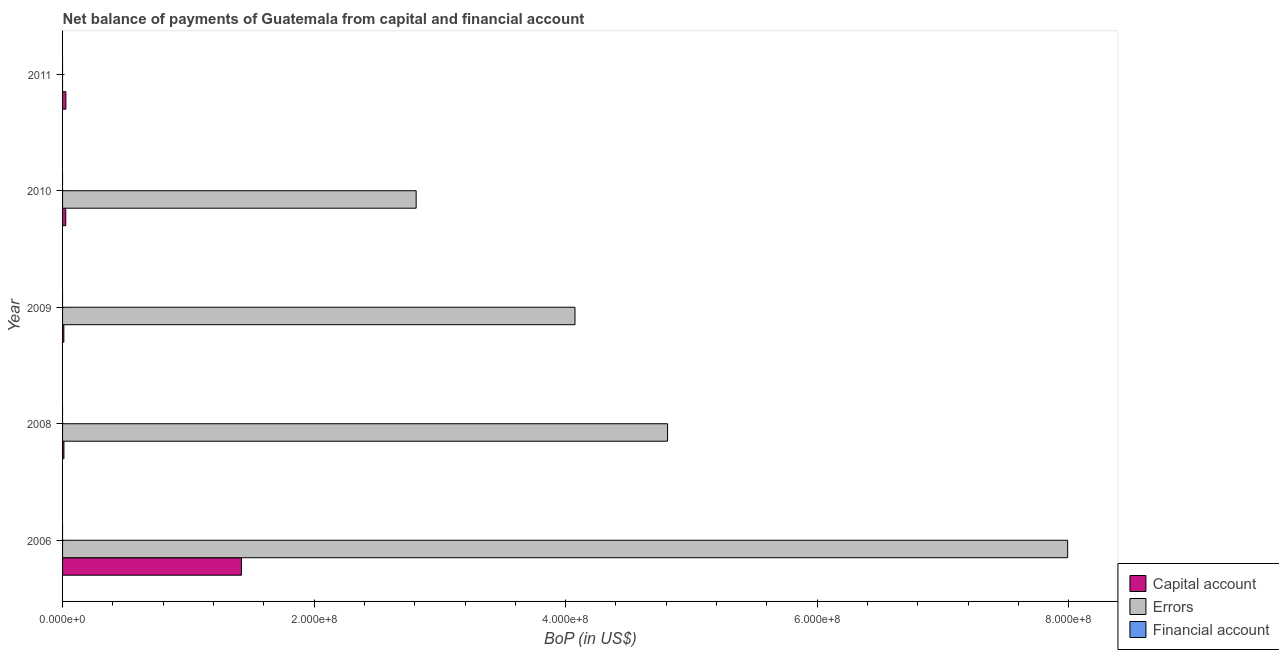How many different coloured bars are there?
Provide a short and direct response. 2. Are the number of bars on each tick of the Y-axis equal?
Keep it short and to the point. No. In how many cases, is the number of bars for a given year not equal to the number of legend labels?
Your answer should be very brief. 5. What is the amount of errors in 2008?
Your answer should be compact. 4.81e+08. Across all years, what is the maximum amount of errors?
Your answer should be very brief. 7.99e+08. Across all years, what is the minimum amount of net capital account?
Ensure brevity in your answer.  1.01e+06. In which year was the amount of errors maximum?
Make the answer very short. 2006. What is the total amount of financial account in the graph?
Give a very brief answer. 0. What is the difference between the amount of errors in 2008 and that in 2009?
Provide a short and direct response. 7.36e+07. What is the difference between the amount of financial account in 2006 and the amount of errors in 2008?
Provide a succinct answer. -4.81e+08. What is the average amount of net capital account per year?
Provide a succinct answer. 2.99e+07. In the year 2008, what is the difference between the amount of net capital account and amount of errors?
Offer a very short reply. -4.80e+08. In how many years, is the amount of net capital account greater than 280000000 US$?
Your response must be concise. 0. What is the ratio of the amount of net capital account in 2006 to that in 2009?
Your response must be concise. 140.53. Is the difference between the amount of net capital account in 2008 and 2009 greater than the difference between the amount of errors in 2008 and 2009?
Give a very brief answer. No. What is the difference between the highest and the second highest amount of errors?
Provide a succinct answer. 3.18e+08. What is the difference between the highest and the lowest amount of errors?
Your answer should be compact. 7.99e+08. In how many years, is the amount of financial account greater than the average amount of financial account taken over all years?
Provide a short and direct response. 0. Is the sum of the amount of net capital account in 2009 and 2010 greater than the maximum amount of financial account across all years?
Your response must be concise. Yes. Is it the case that in every year, the sum of the amount of net capital account and amount of errors is greater than the amount of financial account?
Give a very brief answer. Yes. How many bars are there?
Your answer should be compact. 9. How many years are there in the graph?
Your answer should be very brief. 5. What is the difference between two consecutive major ticks on the X-axis?
Your answer should be very brief. 2.00e+08. Are the values on the major ticks of X-axis written in scientific E-notation?
Ensure brevity in your answer.  Yes. Where does the legend appear in the graph?
Your response must be concise. Bottom right. What is the title of the graph?
Ensure brevity in your answer.  Net balance of payments of Guatemala from capital and financial account. What is the label or title of the X-axis?
Keep it short and to the point. BoP (in US$). What is the BoP (in US$) of Capital account in 2006?
Give a very brief answer. 1.42e+08. What is the BoP (in US$) of Errors in 2006?
Make the answer very short. 7.99e+08. What is the BoP (in US$) of Capital account in 2008?
Ensure brevity in your answer.  1.08e+06. What is the BoP (in US$) of Errors in 2008?
Give a very brief answer. 4.81e+08. What is the BoP (in US$) in Financial account in 2008?
Keep it short and to the point. 0. What is the BoP (in US$) of Capital account in 2009?
Provide a short and direct response. 1.01e+06. What is the BoP (in US$) of Errors in 2009?
Offer a very short reply. 4.07e+08. What is the BoP (in US$) in Financial account in 2009?
Your answer should be compact. 0. What is the BoP (in US$) of Capital account in 2010?
Keep it short and to the point. 2.53e+06. What is the BoP (in US$) in Errors in 2010?
Keep it short and to the point. 2.81e+08. What is the BoP (in US$) in Financial account in 2010?
Make the answer very short. 0. What is the BoP (in US$) of Capital account in 2011?
Your answer should be very brief. 2.63e+06. What is the BoP (in US$) in Errors in 2011?
Provide a short and direct response. 0. What is the BoP (in US$) of Financial account in 2011?
Offer a terse response. 0. Across all years, what is the maximum BoP (in US$) in Capital account?
Keep it short and to the point. 1.42e+08. Across all years, what is the maximum BoP (in US$) of Errors?
Ensure brevity in your answer.  7.99e+08. Across all years, what is the minimum BoP (in US$) in Capital account?
Provide a succinct answer. 1.01e+06. What is the total BoP (in US$) in Capital account in the graph?
Offer a terse response. 1.49e+08. What is the total BoP (in US$) of Errors in the graph?
Make the answer very short. 1.97e+09. What is the total BoP (in US$) of Financial account in the graph?
Offer a terse response. 0. What is the difference between the BoP (in US$) in Capital account in 2006 and that in 2008?
Offer a very short reply. 1.41e+08. What is the difference between the BoP (in US$) in Errors in 2006 and that in 2008?
Provide a succinct answer. 3.18e+08. What is the difference between the BoP (in US$) in Capital account in 2006 and that in 2009?
Provide a short and direct response. 1.41e+08. What is the difference between the BoP (in US$) of Errors in 2006 and that in 2009?
Provide a succinct answer. 3.92e+08. What is the difference between the BoP (in US$) in Capital account in 2006 and that in 2010?
Your response must be concise. 1.40e+08. What is the difference between the BoP (in US$) in Errors in 2006 and that in 2010?
Offer a very short reply. 5.18e+08. What is the difference between the BoP (in US$) in Capital account in 2006 and that in 2011?
Ensure brevity in your answer.  1.40e+08. What is the difference between the BoP (in US$) in Capital account in 2008 and that in 2009?
Provide a short and direct response. 6.75e+04. What is the difference between the BoP (in US$) in Errors in 2008 and that in 2009?
Keep it short and to the point. 7.36e+07. What is the difference between the BoP (in US$) in Capital account in 2008 and that in 2010?
Your answer should be very brief. -1.45e+06. What is the difference between the BoP (in US$) in Errors in 2008 and that in 2010?
Provide a succinct answer. 2.00e+08. What is the difference between the BoP (in US$) of Capital account in 2008 and that in 2011?
Keep it short and to the point. -1.55e+06. What is the difference between the BoP (in US$) in Capital account in 2009 and that in 2010?
Give a very brief answer. -1.52e+06. What is the difference between the BoP (in US$) in Errors in 2009 and that in 2010?
Ensure brevity in your answer.  1.26e+08. What is the difference between the BoP (in US$) of Capital account in 2009 and that in 2011?
Offer a terse response. -1.62e+06. What is the difference between the BoP (in US$) of Capital account in 2010 and that in 2011?
Ensure brevity in your answer.  -9.72e+04. What is the difference between the BoP (in US$) of Capital account in 2006 and the BoP (in US$) of Errors in 2008?
Offer a terse response. -3.39e+08. What is the difference between the BoP (in US$) in Capital account in 2006 and the BoP (in US$) in Errors in 2009?
Your response must be concise. -2.65e+08. What is the difference between the BoP (in US$) of Capital account in 2006 and the BoP (in US$) of Errors in 2010?
Ensure brevity in your answer.  -1.39e+08. What is the difference between the BoP (in US$) of Capital account in 2008 and the BoP (in US$) of Errors in 2009?
Your answer should be compact. -4.06e+08. What is the difference between the BoP (in US$) of Capital account in 2008 and the BoP (in US$) of Errors in 2010?
Give a very brief answer. -2.80e+08. What is the difference between the BoP (in US$) in Capital account in 2009 and the BoP (in US$) in Errors in 2010?
Ensure brevity in your answer.  -2.80e+08. What is the average BoP (in US$) in Capital account per year?
Give a very brief answer. 2.99e+07. What is the average BoP (in US$) of Errors per year?
Keep it short and to the point. 3.94e+08. What is the average BoP (in US$) in Financial account per year?
Keep it short and to the point. 0. In the year 2006, what is the difference between the BoP (in US$) of Capital account and BoP (in US$) of Errors?
Offer a terse response. -6.57e+08. In the year 2008, what is the difference between the BoP (in US$) of Capital account and BoP (in US$) of Errors?
Keep it short and to the point. -4.80e+08. In the year 2009, what is the difference between the BoP (in US$) in Capital account and BoP (in US$) in Errors?
Provide a short and direct response. -4.06e+08. In the year 2010, what is the difference between the BoP (in US$) of Capital account and BoP (in US$) of Errors?
Ensure brevity in your answer.  -2.79e+08. What is the ratio of the BoP (in US$) of Capital account in 2006 to that in 2008?
Provide a short and direct response. 131.74. What is the ratio of the BoP (in US$) in Errors in 2006 to that in 2008?
Provide a succinct answer. 1.66. What is the ratio of the BoP (in US$) of Capital account in 2006 to that in 2009?
Offer a very short reply. 140.53. What is the ratio of the BoP (in US$) of Errors in 2006 to that in 2009?
Your response must be concise. 1.96. What is the ratio of the BoP (in US$) in Capital account in 2006 to that in 2010?
Offer a terse response. 56.14. What is the ratio of the BoP (in US$) in Errors in 2006 to that in 2010?
Your response must be concise. 2.84. What is the ratio of the BoP (in US$) of Capital account in 2006 to that in 2011?
Your answer should be compact. 54.06. What is the ratio of the BoP (in US$) of Capital account in 2008 to that in 2009?
Keep it short and to the point. 1.07. What is the ratio of the BoP (in US$) in Errors in 2008 to that in 2009?
Your answer should be very brief. 1.18. What is the ratio of the BoP (in US$) in Capital account in 2008 to that in 2010?
Your response must be concise. 0.43. What is the ratio of the BoP (in US$) in Errors in 2008 to that in 2010?
Your answer should be very brief. 1.71. What is the ratio of the BoP (in US$) of Capital account in 2008 to that in 2011?
Ensure brevity in your answer.  0.41. What is the ratio of the BoP (in US$) in Capital account in 2009 to that in 2010?
Keep it short and to the point. 0.4. What is the ratio of the BoP (in US$) of Errors in 2009 to that in 2010?
Offer a very short reply. 1.45. What is the ratio of the BoP (in US$) in Capital account in 2009 to that in 2011?
Ensure brevity in your answer.  0.38. What is the difference between the highest and the second highest BoP (in US$) in Capital account?
Ensure brevity in your answer.  1.40e+08. What is the difference between the highest and the second highest BoP (in US$) in Errors?
Your response must be concise. 3.18e+08. What is the difference between the highest and the lowest BoP (in US$) of Capital account?
Offer a very short reply. 1.41e+08. What is the difference between the highest and the lowest BoP (in US$) in Errors?
Provide a short and direct response. 7.99e+08. 